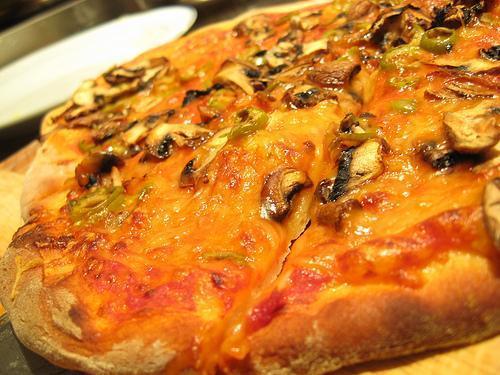How many pizzas are there?
Give a very brief answer. 1. 